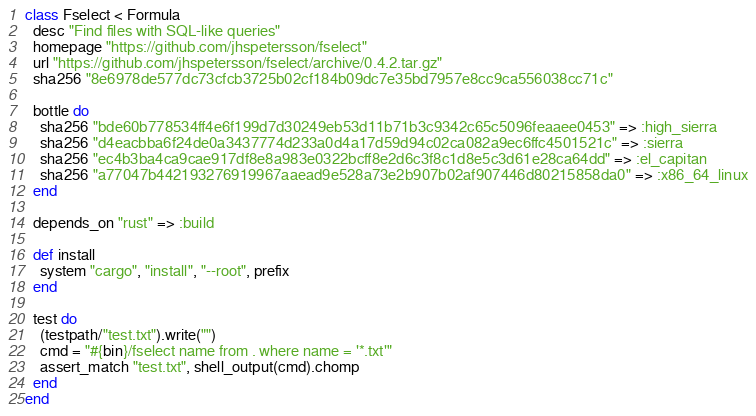Convert code to text. <code><loc_0><loc_0><loc_500><loc_500><_Ruby_>class Fselect < Formula
  desc "Find files with SQL-like queries"
  homepage "https://github.com/jhspetersson/fselect"
  url "https://github.com/jhspetersson/fselect/archive/0.4.2.tar.gz"
  sha256 "8e6978de577dc73cfcb3725b02cf184b09dc7e35bd7957e8cc9ca556038cc71c"

  bottle do
    sha256 "bde60b778534ff4e6f199d7d30249eb53d11b71b3c9342c65c5096feaaee0453" => :high_sierra
    sha256 "d4eacbba6f24de0a3437774d233a0d4a17d59d94c02ca082a9ec6ffc4501521c" => :sierra
    sha256 "ec4b3ba4ca9cae917df8e8a983e0322bcff8e2d6c3f8c1d8e5c3d61e28ca64dd" => :el_capitan
    sha256 "a77047b442193276919967aaead9e528a73e2b907b02af907446d80215858da0" => :x86_64_linux
  end

  depends_on "rust" => :build

  def install
    system "cargo", "install", "--root", prefix
  end

  test do
    (testpath/"test.txt").write("")
    cmd = "#{bin}/fselect name from . where name = '*.txt'"
    assert_match "test.txt", shell_output(cmd).chomp
  end
end
</code> 